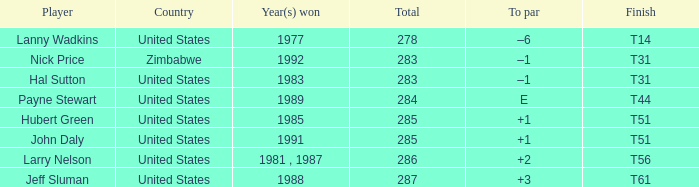What was the finish for the year 1991 when it was won? T51. 